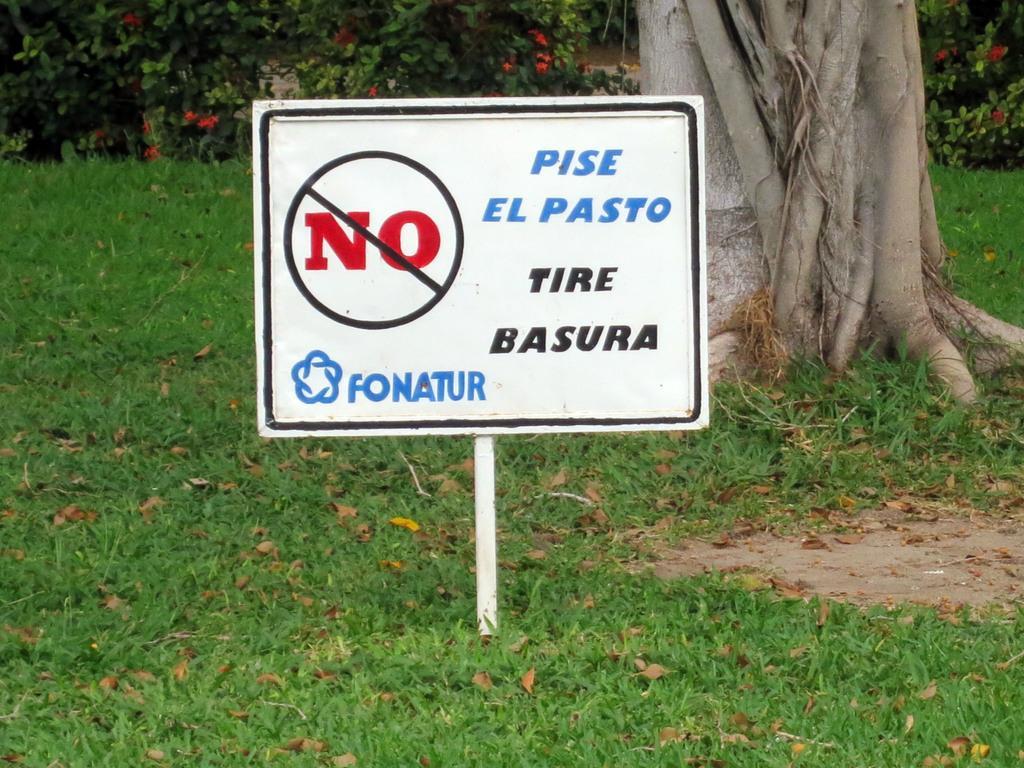Please provide a concise description of this image. In the picture I can see a board which is inside ground and there are some words written on it and in the background of the picture there are some plants, grass and trunk of a tree. 